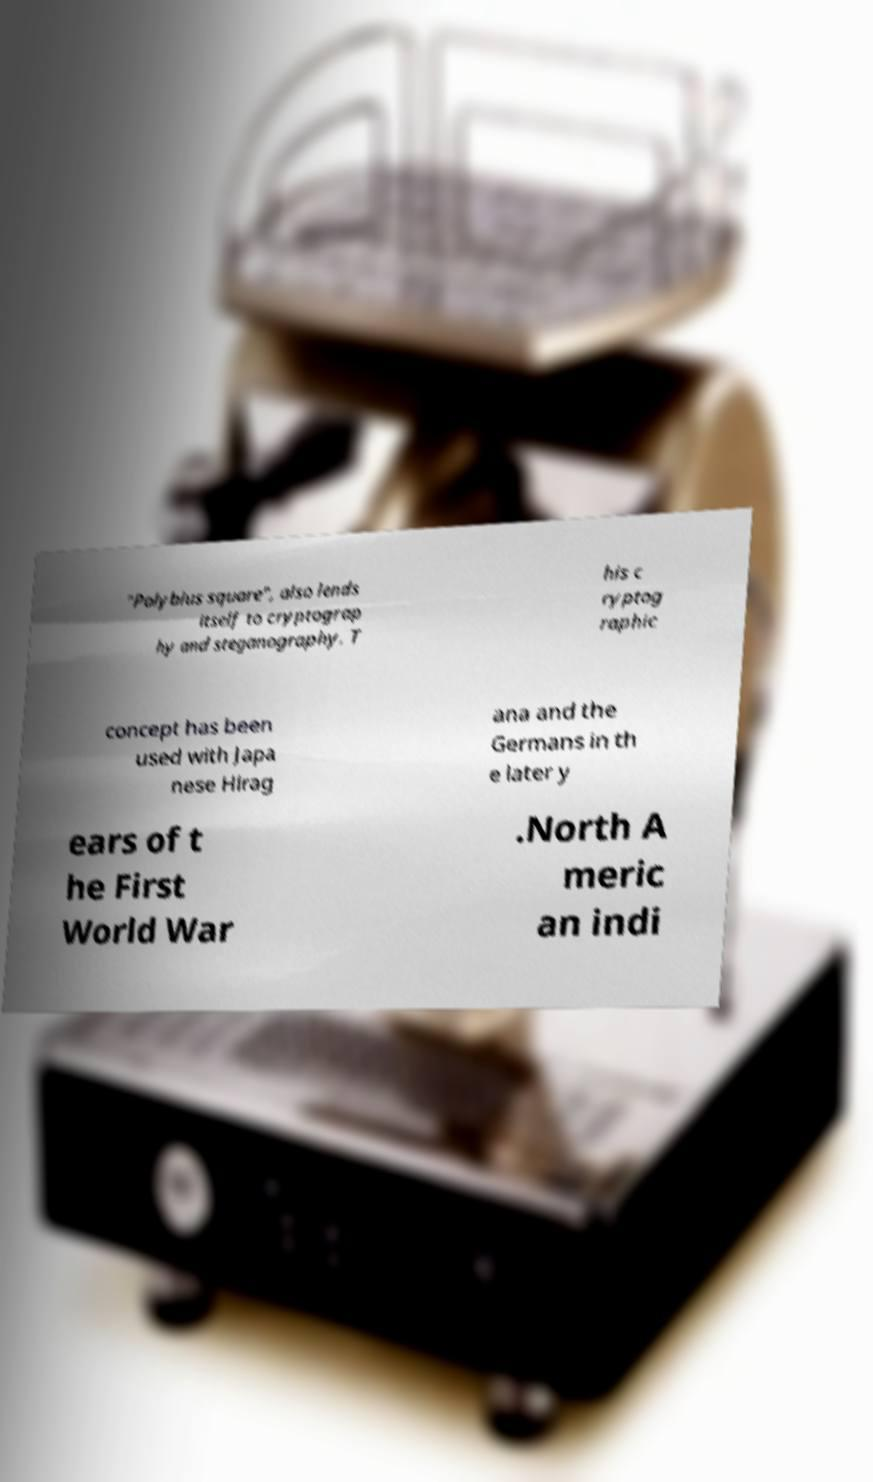Please read and relay the text visible in this image. What does it say? "Polybius square", also lends itself to cryptograp hy and steganography. T his c ryptog raphic concept has been used with Japa nese Hirag ana and the Germans in th e later y ears of t he First World War .North A meric an indi 